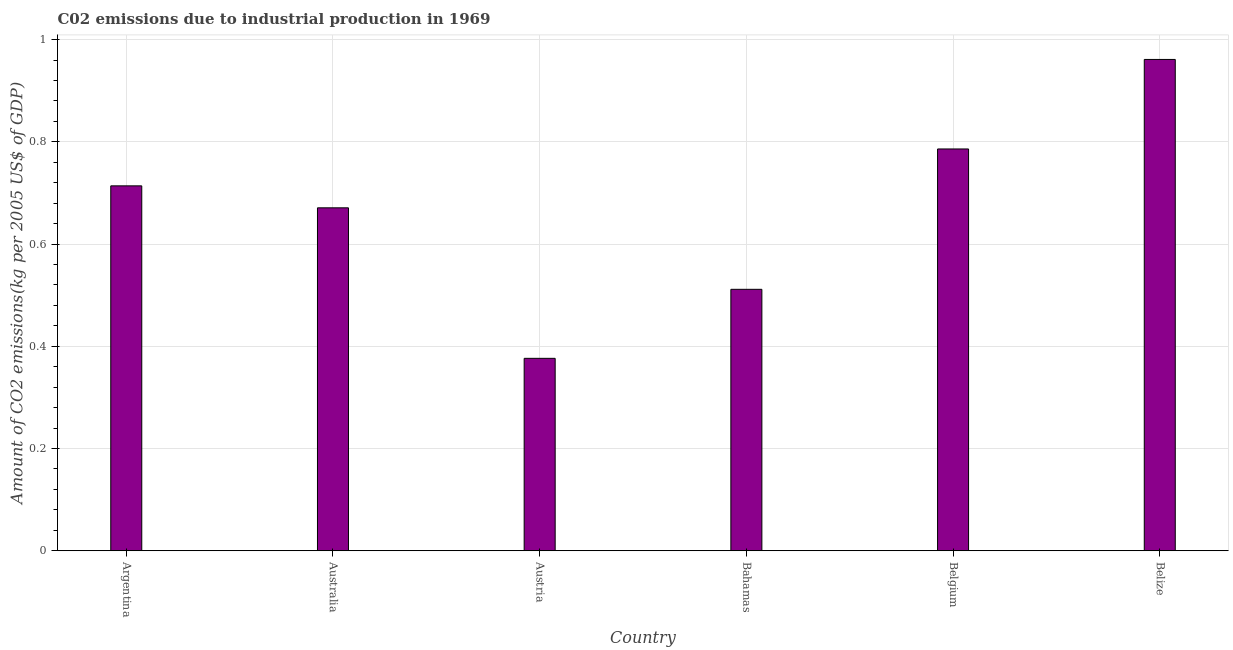Does the graph contain grids?
Give a very brief answer. Yes. What is the title of the graph?
Provide a short and direct response. C02 emissions due to industrial production in 1969. What is the label or title of the Y-axis?
Make the answer very short. Amount of CO2 emissions(kg per 2005 US$ of GDP). What is the amount of co2 emissions in Australia?
Your response must be concise. 0.67. Across all countries, what is the maximum amount of co2 emissions?
Ensure brevity in your answer.  0.96. Across all countries, what is the minimum amount of co2 emissions?
Your response must be concise. 0.38. In which country was the amount of co2 emissions maximum?
Make the answer very short. Belize. In which country was the amount of co2 emissions minimum?
Your response must be concise. Austria. What is the sum of the amount of co2 emissions?
Provide a succinct answer. 4.02. What is the difference between the amount of co2 emissions in Argentina and Bahamas?
Your answer should be very brief. 0.2. What is the average amount of co2 emissions per country?
Offer a very short reply. 0.67. What is the median amount of co2 emissions?
Your answer should be compact. 0.69. What is the ratio of the amount of co2 emissions in Argentina to that in Belize?
Offer a very short reply. 0.74. Is the amount of co2 emissions in Argentina less than that in Austria?
Your answer should be compact. No. Is the difference between the amount of co2 emissions in Argentina and Austria greater than the difference between any two countries?
Keep it short and to the point. No. What is the difference between the highest and the second highest amount of co2 emissions?
Offer a very short reply. 0.17. What is the difference between the highest and the lowest amount of co2 emissions?
Offer a terse response. 0.58. How many bars are there?
Provide a succinct answer. 6. What is the Amount of CO2 emissions(kg per 2005 US$ of GDP) of Argentina?
Make the answer very short. 0.71. What is the Amount of CO2 emissions(kg per 2005 US$ of GDP) in Australia?
Provide a short and direct response. 0.67. What is the Amount of CO2 emissions(kg per 2005 US$ of GDP) of Austria?
Ensure brevity in your answer.  0.38. What is the Amount of CO2 emissions(kg per 2005 US$ of GDP) of Bahamas?
Offer a terse response. 0.51. What is the Amount of CO2 emissions(kg per 2005 US$ of GDP) in Belgium?
Ensure brevity in your answer.  0.79. What is the Amount of CO2 emissions(kg per 2005 US$ of GDP) of Belize?
Your answer should be compact. 0.96. What is the difference between the Amount of CO2 emissions(kg per 2005 US$ of GDP) in Argentina and Australia?
Your answer should be compact. 0.04. What is the difference between the Amount of CO2 emissions(kg per 2005 US$ of GDP) in Argentina and Austria?
Offer a very short reply. 0.34. What is the difference between the Amount of CO2 emissions(kg per 2005 US$ of GDP) in Argentina and Bahamas?
Provide a succinct answer. 0.2. What is the difference between the Amount of CO2 emissions(kg per 2005 US$ of GDP) in Argentina and Belgium?
Provide a succinct answer. -0.07. What is the difference between the Amount of CO2 emissions(kg per 2005 US$ of GDP) in Argentina and Belize?
Your answer should be very brief. -0.25. What is the difference between the Amount of CO2 emissions(kg per 2005 US$ of GDP) in Australia and Austria?
Ensure brevity in your answer.  0.29. What is the difference between the Amount of CO2 emissions(kg per 2005 US$ of GDP) in Australia and Bahamas?
Offer a terse response. 0.16. What is the difference between the Amount of CO2 emissions(kg per 2005 US$ of GDP) in Australia and Belgium?
Ensure brevity in your answer.  -0.12. What is the difference between the Amount of CO2 emissions(kg per 2005 US$ of GDP) in Australia and Belize?
Make the answer very short. -0.29. What is the difference between the Amount of CO2 emissions(kg per 2005 US$ of GDP) in Austria and Bahamas?
Your answer should be compact. -0.14. What is the difference between the Amount of CO2 emissions(kg per 2005 US$ of GDP) in Austria and Belgium?
Your answer should be very brief. -0.41. What is the difference between the Amount of CO2 emissions(kg per 2005 US$ of GDP) in Austria and Belize?
Provide a short and direct response. -0.58. What is the difference between the Amount of CO2 emissions(kg per 2005 US$ of GDP) in Bahamas and Belgium?
Give a very brief answer. -0.27. What is the difference between the Amount of CO2 emissions(kg per 2005 US$ of GDP) in Bahamas and Belize?
Provide a short and direct response. -0.45. What is the difference between the Amount of CO2 emissions(kg per 2005 US$ of GDP) in Belgium and Belize?
Provide a short and direct response. -0.18. What is the ratio of the Amount of CO2 emissions(kg per 2005 US$ of GDP) in Argentina to that in Australia?
Provide a succinct answer. 1.06. What is the ratio of the Amount of CO2 emissions(kg per 2005 US$ of GDP) in Argentina to that in Austria?
Your answer should be very brief. 1.9. What is the ratio of the Amount of CO2 emissions(kg per 2005 US$ of GDP) in Argentina to that in Bahamas?
Offer a very short reply. 1.4. What is the ratio of the Amount of CO2 emissions(kg per 2005 US$ of GDP) in Argentina to that in Belgium?
Keep it short and to the point. 0.91. What is the ratio of the Amount of CO2 emissions(kg per 2005 US$ of GDP) in Argentina to that in Belize?
Ensure brevity in your answer.  0.74. What is the ratio of the Amount of CO2 emissions(kg per 2005 US$ of GDP) in Australia to that in Austria?
Keep it short and to the point. 1.78. What is the ratio of the Amount of CO2 emissions(kg per 2005 US$ of GDP) in Australia to that in Bahamas?
Ensure brevity in your answer.  1.31. What is the ratio of the Amount of CO2 emissions(kg per 2005 US$ of GDP) in Australia to that in Belgium?
Offer a very short reply. 0.85. What is the ratio of the Amount of CO2 emissions(kg per 2005 US$ of GDP) in Australia to that in Belize?
Offer a very short reply. 0.7. What is the ratio of the Amount of CO2 emissions(kg per 2005 US$ of GDP) in Austria to that in Bahamas?
Provide a short and direct response. 0.74. What is the ratio of the Amount of CO2 emissions(kg per 2005 US$ of GDP) in Austria to that in Belgium?
Your answer should be very brief. 0.48. What is the ratio of the Amount of CO2 emissions(kg per 2005 US$ of GDP) in Austria to that in Belize?
Keep it short and to the point. 0.39. What is the ratio of the Amount of CO2 emissions(kg per 2005 US$ of GDP) in Bahamas to that in Belgium?
Offer a terse response. 0.65. What is the ratio of the Amount of CO2 emissions(kg per 2005 US$ of GDP) in Bahamas to that in Belize?
Offer a very short reply. 0.53. What is the ratio of the Amount of CO2 emissions(kg per 2005 US$ of GDP) in Belgium to that in Belize?
Your answer should be compact. 0.82. 